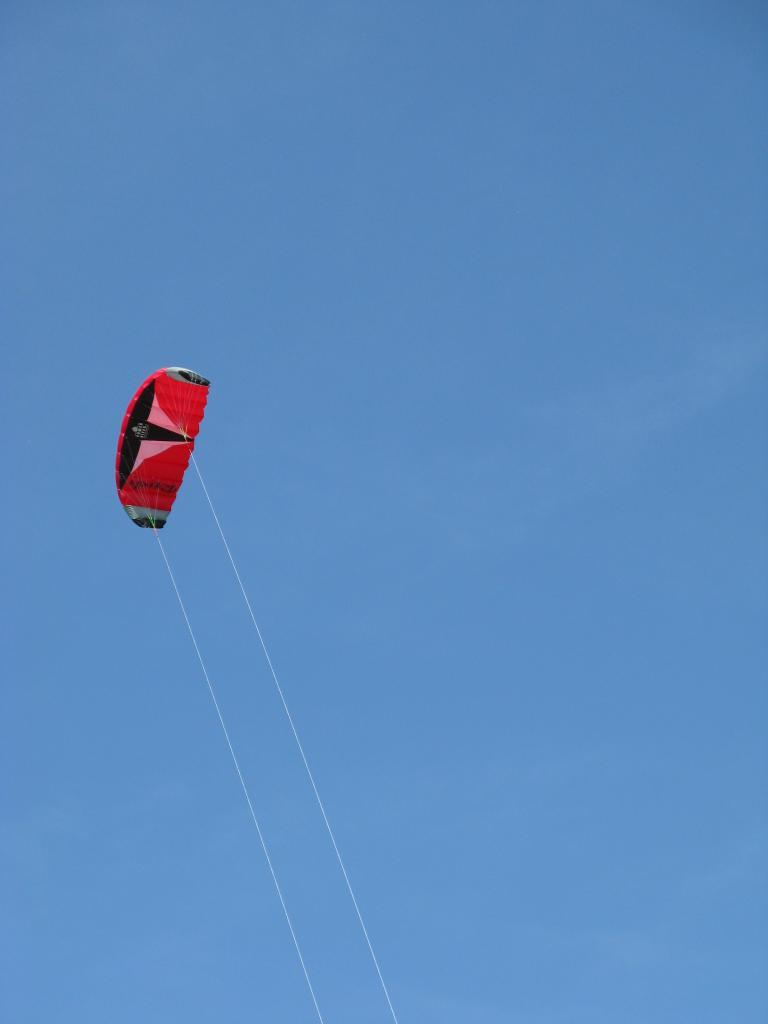What is suspended in the air in the image? There is a parachute in the air. How many threads are attached to the parachute? The parachute has two threads. What color is the sky in the background of the image? The sky is blue in the background. What type of stamp is visible on the parachute in the image? There is no stamp present on the parachute in the image. 